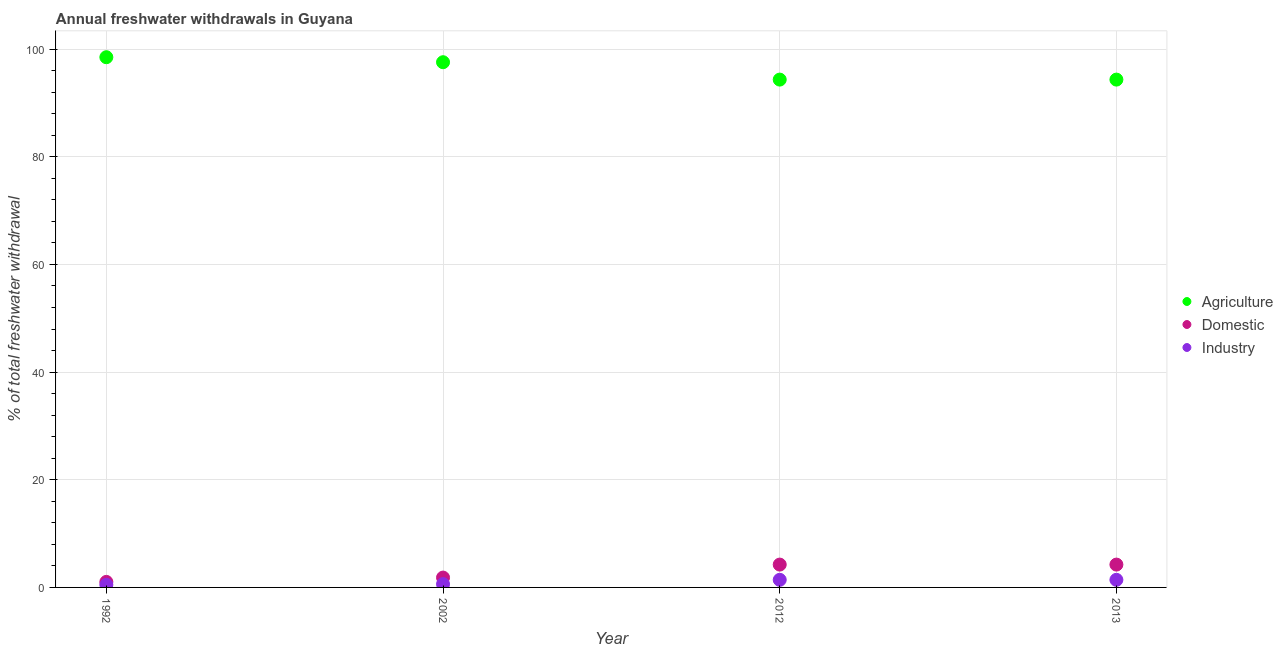Is the number of dotlines equal to the number of legend labels?
Your response must be concise. Yes. What is the percentage of freshwater withdrawal for domestic purposes in 2012?
Give a very brief answer. 4.24. Across all years, what is the maximum percentage of freshwater withdrawal for domestic purposes?
Your answer should be very brief. 4.24. Across all years, what is the minimum percentage of freshwater withdrawal for agriculture?
Ensure brevity in your answer.  94.33. What is the total percentage of freshwater withdrawal for agriculture in the graph?
Ensure brevity in your answer.  384.71. What is the difference between the percentage of freshwater withdrawal for domestic purposes in 2012 and that in 2013?
Your answer should be very brief. 0. What is the difference between the percentage of freshwater withdrawal for agriculture in 2013 and the percentage of freshwater withdrawal for industry in 2002?
Offer a terse response. 93.72. What is the average percentage of freshwater withdrawal for agriculture per year?
Offer a terse response. 96.18. In the year 1992, what is the difference between the percentage of freshwater withdrawal for agriculture and percentage of freshwater withdrawal for domestic purposes?
Offer a terse response. 97.46. What is the ratio of the percentage of freshwater withdrawal for agriculture in 1992 to that in 2013?
Make the answer very short. 1.04. Is the percentage of freshwater withdrawal for domestic purposes in 1992 less than that in 2013?
Provide a succinct answer. Yes. What is the difference between the highest and the second highest percentage of freshwater withdrawal for domestic purposes?
Provide a succinct answer. 0. What is the difference between the highest and the lowest percentage of freshwater withdrawal for agriculture?
Provide a short and direct response. 4.16. Is the percentage of freshwater withdrawal for industry strictly greater than the percentage of freshwater withdrawal for agriculture over the years?
Your answer should be very brief. No. Is the percentage of freshwater withdrawal for domestic purposes strictly less than the percentage of freshwater withdrawal for industry over the years?
Your answer should be very brief. No. What is the difference between two consecutive major ticks on the Y-axis?
Your response must be concise. 20. Does the graph contain any zero values?
Ensure brevity in your answer.  No. How many legend labels are there?
Keep it short and to the point. 3. How are the legend labels stacked?
Provide a short and direct response. Vertical. What is the title of the graph?
Keep it short and to the point. Annual freshwater withdrawals in Guyana. Does "Renewable sources" appear as one of the legend labels in the graph?
Your answer should be compact. No. What is the label or title of the Y-axis?
Provide a short and direct response. % of total freshwater withdrawal. What is the % of total freshwater withdrawal in Agriculture in 1992?
Make the answer very short. 98.49. What is the % of total freshwater withdrawal of Industry in 1992?
Ensure brevity in your answer.  0.48. What is the % of total freshwater withdrawal in Agriculture in 2002?
Make the answer very short. 97.56. What is the % of total freshwater withdrawal in Domestic in 2002?
Offer a terse response. 1.83. What is the % of total freshwater withdrawal in Industry in 2002?
Provide a succinct answer. 0.61. What is the % of total freshwater withdrawal in Agriculture in 2012?
Make the answer very short. 94.33. What is the % of total freshwater withdrawal of Domestic in 2012?
Offer a very short reply. 4.24. What is the % of total freshwater withdrawal in Industry in 2012?
Ensure brevity in your answer.  1.41. What is the % of total freshwater withdrawal in Agriculture in 2013?
Offer a terse response. 94.33. What is the % of total freshwater withdrawal in Domestic in 2013?
Give a very brief answer. 4.24. What is the % of total freshwater withdrawal of Industry in 2013?
Provide a succinct answer. 1.41. Across all years, what is the maximum % of total freshwater withdrawal in Agriculture?
Keep it short and to the point. 98.49. Across all years, what is the maximum % of total freshwater withdrawal in Domestic?
Provide a short and direct response. 4.24. Across all years, what is the maximum % of total freshwater withdrawal of Industry?
Your answer should be compact. 1.41. Across all years, what is the minimum % of total freshwater withdrawal of Agriculture?
Provide a succinct answer. 94.33. Across all years, what is the minimum % of total freshwater withdrawal of Industry?
Make the answer very short. 0.48. What is the total % of total freshwater withdrawal in Agriculture in the graph?
Your answer should be compact. 384.71. What is the total % of total freshwater withdrawal in Domestic in the graph?
Make the answer very short. 11.34. What is the total % of total freshwater withdrawal in Industry in the graph?
Your response must be concise. 3.91. What is the difference between the % of total freshwater withdrawal in Agriculture in 1992 and that in 2002?
Your answer should be very brief. 0.93. What is the difference between the % of total freshwater withdrawal of Domestic in 1992 and that in 2002?
Your answer should be compact. -0.8. What is the difference between the % of total freshwater withdrawal of Industry in 1992 and that in 2002?
Ensure brevity in your answer.  -0.13. What is the difference between the % of total freshwater withdrawal of Agriculture in 1992 and that in 2012?
Offer a terse response. 4.16. What is the difference between the % of total freshwater withdrawal of Domestic in 1992 and that in 2012?
Ensure brevity in your answer.  -3.21. What is the difference between the % of total freshwater withdrawal of Industry in 1992 and that in 2012?
Offer a terse response. -0.93. What is the difference between the % of total freshwater withdrawal of Agriculture in 1992 and that in 2013?
Ensure brevity in your answer.  4.16. What is the difference between the % of total freshwater withdrawal in Domestic in 1992 and that in 2013?
Offer a terse response. -3.21. What is the difference between the % of total freshwater withdrawal in Industry in 1992 and that in 2013?
Make the answer very short. -0.93. What is the difference between the % of total freshwater withdrawal of Agriculture in 2002 and that in 2012?
Make the answer very short. 3.23. What is the difference between the % of total freshwater withdrawal in Domestic in 2002 and that in 2012?
Make the answer very short. -2.41. What is the difference between the % of total freshwater withdrawal of Industry in 2002 and that in 2012?
Provide a succinct answer. -0.8. What is the difference between the % of total freshwater withdrawal in Agriculture in 2002 and that in 2013?
Offer a very short reply. 3.23. What is the difference between the % of total freshwater withdrawal of Domestic in 2002 and that in 2013?
Your answer should be compact. -2.41. What is the difference between the % of total freshwater withdrawal of Industry in 2002 and that in 2013?
Make the answer very short. -0.8. What is the difference between the % of total freshwater withdrawal in Agriculture in 2012 and that in 2013?
Your answer should be compact. 0. What is the difference between the % of total freshwater withdrawal in Agriculture in 1992 and the % of total freshwater withdrawal in Domestic in 2002?
Make the answer very short. 96.66. What is the difference between the % of total freshwater withdrawal in Agriculture in 1992 and the % of total freshwater withdrawal in Industry in 2002?
Your answer should be compact. 97.88. What is the difference between the % of total freshwater withdrawal in Domestic in 1992 and the % of total freshwater withdrawal in Industry in 2002?
Give a very brief answer. 0.42. What is the difference between the % of total freshwater withdrawal of Agriculture in 1992 and the % of total freshwater withdrawal of Domestic in 2012?
Your answer should be compact. 94.25. What is the difference between the % of total freshwater withdrawal of Agriculture in 1992 and the % of total freshwater withdrawal of Industry in 2012?
Offer a very short reply. 97.08. What is the difference between the % of total freshwater withdrawal of Domestic in 1992 and the % of total freshwater withdrawal of Industry in 2012?
Keep it short and to the point. -0.39. What is the difference between the % of total freshwater withdrawal in Agriculture in 1992 and the % of total freshwater withdrawal in Domestic in 2013?
Your answer should be very brief. 94.25. What is the difference between the % of total freshwater withdrawal of Agriculture in 1992 and the % of total freshwater withdrawal of Industry in 2013?
Provide a succinct answer. 97.08. What is the difference between the % of total freshwater withdrawal in Domestic in 1992 and the % of total freshwater withdrawal in Industry in 2013?
Give a very brief answer. -0.39. What is the difference between the % of total freshwater withdrawal in Agriculture in 2002 and the % of total freshwater withdrawal in Domestic in 2012?
Offer a terse response. 93.32. What is the difference between the % of total freshwater withdrawal of Agriculture in 2002 and the % of total freshwater withdrawal of Industry in 2012?
Offer a very short reply. 96.15. What is the difference between the % of total freshwater withdrawal in Domestic in 2002 and the % of total freshwater withdrawal in Industry in 2012?
Offer a very short reply. 0.42. What is the difference between the % of total freshwater withdrawal in Agriculture in 2002 and the % of total freshwater withdrawal in Domestic in 2013?
Offer a very short reply. 93.32. What is the difference between the % of total freshwater withdrawal of Agriculture in 2002 and the % of total freshwater withdrawal of Industry in 2013?
Your answer should be compact. 96.15. What is the difference between the % of total freshwater withdrawal in Domestic in 2002 and the % of total freshwater withdrawal in Industry in 2013?
Your answer should be compact. 0.42. What is the difference between the % of total freshwater withdrawal in Agriculture in 2012 and the % of total freshwater withdrawal in Domestic in 2013?
Give a very brief answer. 90.09. What is the difference between the % of total freshwater withdrawal in Agriculture in 2012 and the % of total freshwater withdrawal in Industry in 2013?
Your answer should be compact. 92.92. What is the difference between the % of total freshwater withdrawal of Domestic in 2012 and the % of total freshwater withdrawal of Industry in 2013?
Offer a very short reply. 2.83. What is the average % of total freshwater withdrawal in Agriculture per year?
Offer a very short reply. 96.18. What is the average % of total freshwater withdrawal of Domestic per year?
Make the answer very short. 2.83. What is the average % of total freshwater withdrawal in Industry per year?
Your answer should be very brief. 0.98. In the year 1992, what is the difference between the % of total freshwater withdrawal of Agriculture and % of total freshwater withdrawal of Domestic?
Your answer should be very brief. 97.46. In the year 1992, what is the difference between the % of total freshwater withdrawal of Agriculture and % of total freshwater withdrawal of Industry?
Your answer should be very brief. 98.01. In the year 1992, what is the difference between the % of total freshwater withdrawal of Domestic and % of total freshwater withdrawal of Industry?
Provide a succinct answer. 0.55. In the year 2002, what is the difference between the % of total freshwater withdrawal in Agriculture and % of total freshwater withdrawal in Domestic?
Offer a terse response. 95.73. In the year 2002, what is the difference between the % of total freshwater withdrawal of Agriculture and % of total freshwater withdrawal of Industry?
Your answer should be compact. 96.95. In the year 2002, what is the difference between the % of total freshwater withdrawal of Domestic and % of total freshwater withdrawal of Industry?
Your response must be concise. 1.22. In the year 2012, what is the difference between the % of total freshwater withdrawal in Agriculture and % of total freshwater withdrawal in Domestic?
Your response must be concise. 90.09. In the year 2012, what is the difference between the % of total freshwater withdrawal of Agriculture and % of total freshwater withdrawal of Industry?
Ensure brevity in your answer.  92.92. In the year 2012, what is the difference between the % of total freshwater withdrawal in Domestic and % of total freshwater withdrawal in Industry?
Give a very brief answer. 2.83. In the year 2013, what is the difference between the % of total freshwater withdrawal of Agriculture and % of total freshwater withdrawal of Domestic?
Provide a short and direct response. 90.09. In the year 2013, what is the difference between the % of total freshwater withdrawal in Agriculture and % of total freshwater withdrawal in Industry?
Provide a short and direct response. 92.92. In the year 2013, what is the difference between the % of total freshwater withdrawal of Domestic and % of total freshwater withdrawal of Industry?
Offer a terse response. 2.83. What is the ratio of the % of total freshwater withdrawal in Agriculture in 1992 to that in 2002?
Keep it short and to the point. 1.01. What is the ratio of the % of total freshwater withdrawal in Domestic in 1992 to that in 2002?
Your answer should be compact. 0.56. What is the ratio of the % of total freshwater withdrawal in Industry in 1992 to that in 2002?
Give a very brief answer. 0.79. What is the ratio of the % of total freshwater withdrawal in Agriculture in 1992 to that in 2012?
Keep it short and to the point. 1.04. What is the ratio of the % of total freshwater withdrawal in Domestic in 1992 to that in 2012?
Your answer should be compact. 0.24. What is the ratio of the % of total freshwater withdrawal of Industry in 1992 to that in 2012?
Offer a very short reply. 0.34. What is the ratio of the % of total freshwater withdrawal of Agriculture in 1992 to that in 2013?
Make the answer very short. 1.04. What is the ratio of the % of total freshwater withdrawal in Domestic in 1992 to that in 2013?
Offer a terse response. 0.24. What is the ratio of the % of total freshwater withdrawal of Industry in 1992 to that in 2013?
Offer a terse response. 0.34. What is the ratio of the % of total freshwater withdrawal in Agriculture in 2002 to that in 2012?
Make the answer very short. 1.03. What is the ratio of the % of total freshwater withdrawal of Domestic in 2002 to that in 2012?
Your answer should be compact. 0.43. What is the ratio of the % of total freshwater withdrawal in Industry in 2002 to that in 2012?
Make the answer very short. 0.43. What is the ratio of the % of total freshwater withdrawal in Agriculture in 2002 to that in 2013?
Offer a terse response. 1.03. What is the ratio of the % of total freshwater withdrawal in Domestic in 2002 to that in 2013?
Ensure brevity in your answer.  0.43. What is the ratio of the % of total freshwater withdrawal in Industry in 2002 to that in 2013?
Give a very brief answer. 0.43. What is the difference between the highest and the lowest % of total freshwater withdrawal in Agriculture?
Provide a short and direct response. 4.16. What is the difference between the highest and the lowest % of total freshwater withdrawal in Domestic?
Provide a short and direct response. 3.21. What is the difference between the highest and the lowest % of total freshwater withdrawal of Industry?
Give a very brief answer. 0.93. 